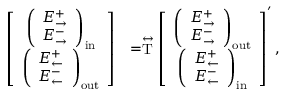<formula> <loc_0><loc_0><loc_500><loc_500>\begin{array} { r l } { \left [ \begin{array} { c } { \left ( \begin{array} { c } { E _ { \rightarrow } ^ { + } } \\ { E _ { \rightarrow } ^ { - } } \end{array} \right ) _ { i n } } \\ { \left ( \begin{array} { c } { E _ { \leftarrow } ^ { + } } \\ { E _ { \leftarrow } ^ { - } } \end{array} \right ) _ { o u t } } \end{array} \right ] } & { = \stackrel { \leftrightarrow } { T } \left [ \begin{array} { c } { \left ( \begin{array} { c } { E _ { \rightarrow } ^ { + } } \\ { E _ { \rightarrow } ^ { - } } \end{array} \right ) _ { o u t } } \\ { \left ( \begin{array} { c } { E _ { \leftarrow } ^ { + } } \\ { E _ { \leftarrow } ^ { - } } \end{array} \right ) _ { i n } } \end{array} \right ] ^ { \prime } , } \end{array}</formula> 